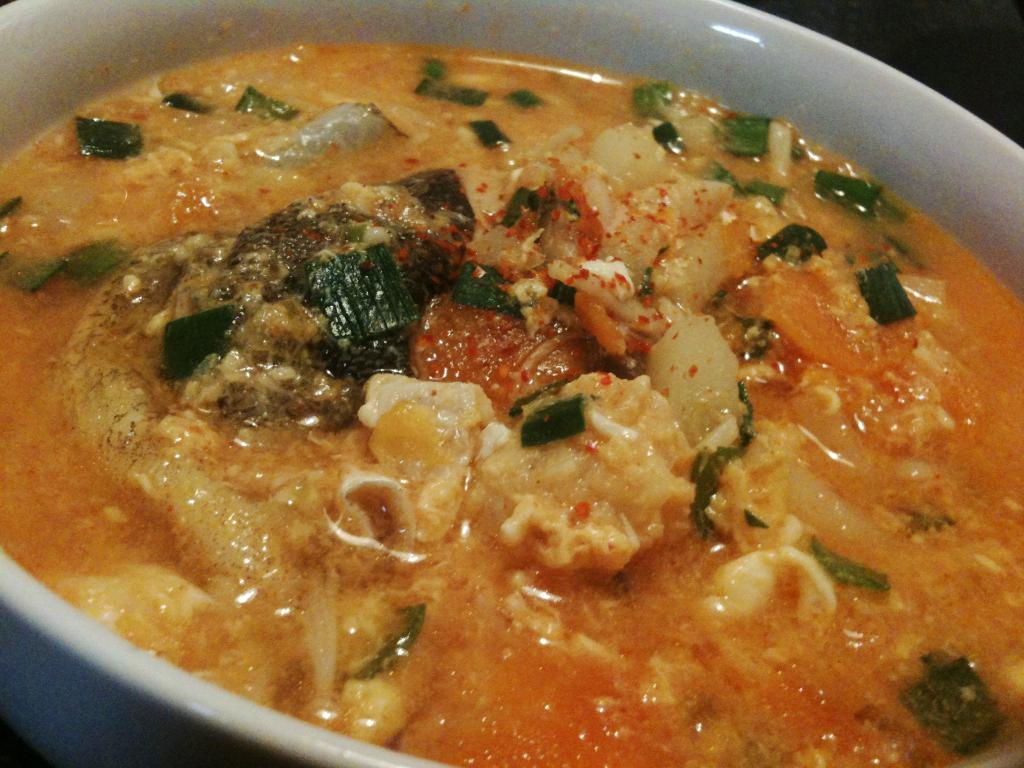What is present in the image? There is a bowl in the image. What is inside the bowl? There is food in the bowl. What type of quince is being sliced by the hands in the image? There is no quince or hands present in the image. The image only contains a bowl with food in it. 